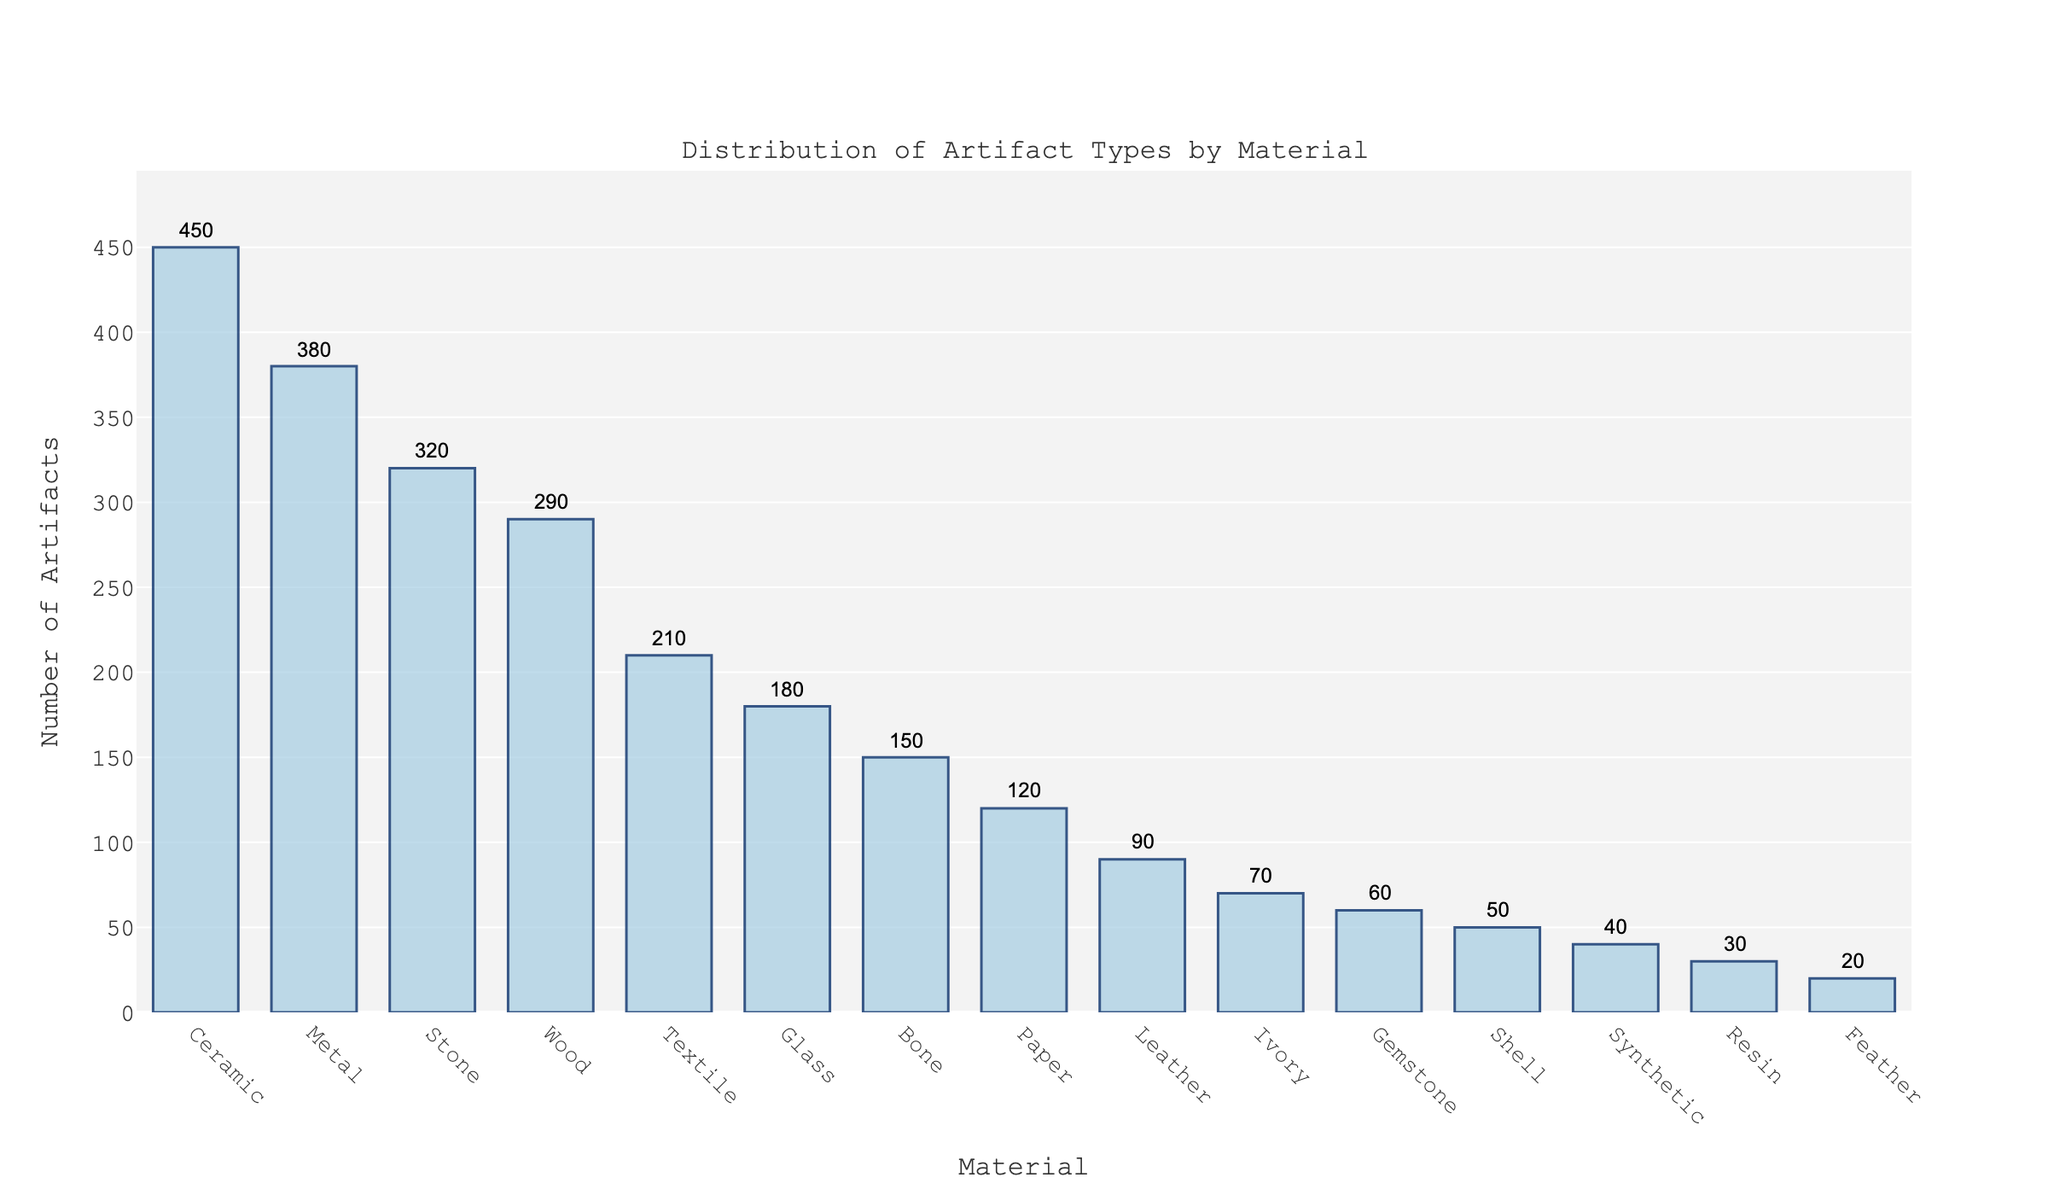Which material has the highest number of artifacts? The bar for Ceramic is the tallest and annotated with the highest number, 450.
Answer: Ceramic How many more artifacts are made of Ceramic than Wood? Ceramic has 450 artifacts and Wood has 290 artifacts. The difference is 450 - 290 = 160.
Answer: 160 What is the total number of artifacts made from Bone and Shell combined? Bone has 150 artifacts and Shell has 50 artifacts. Their sum is 150 + 50 = 200.
Answer: 200 Which material has fewer artifacts, Glass or Textile? By comparing the heights of the bars and their annotations, Glass has 180 artifacts, and Textile has 210 artifacts. Thus, Glass has fewer artifacts.
Answer: Glass What is the average number of artifacts for Ceramic, Metal, and Stone? Ceramic has 450 artifacts, Metal has 380 artifacts, and Stone has 320 artifacts. Their total is 450 + 380 + 320 = 1150. The average is 1150 / 3 = 383.33.
Answer: 383.33 How does the number of artifacts made from Ivory compare to those made from Leather? Ivory has 70 artifacts, while Leather has 90 artifacts. Comparing the numbers, Ivory has fewer artifacts.
Answer: Ivory Are there more artifacts made from Wood or Stone? By comparing the heights of the bars and their annotations, Wood has 290 artifacts, while Stone has 320 artifacts. Therefore, Stone has more artifacts.
Answer: Stone What's the sum of artifacts made from the top 3 materials? The top 3 materials are Ceramic (450), Metal (380), and Stone (320). Their sum is 450 + 380 + 320 = 1150.
Answer: 1150 Which material has the second least number of artifacts and how many? From the sorted list, Feather has 20 artifacts, Resin has 30 artifacts. Therefore, Resin is the second least with 30 artifacts.
Answer: Resin, 30 What is the range of artifacts for the materials provided? The highest number of artifacts is 450 (Ceramic), and the lowest is 20 (Feather). The range is 450 - 20 = 430.
Answer: 430 